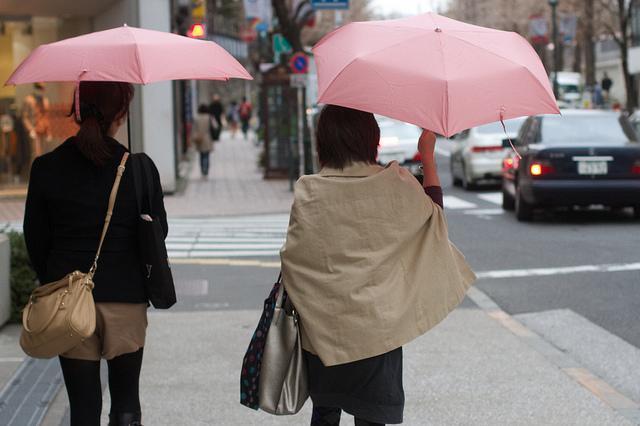How many handbags are there?
Give a very brief answer. 2. How many cars can be seen?
Give a very brief answer. 3. How many people are in the picture?
Give a very brief answer. 2. How many umbrellas are there?
Give a very brief answer. 2. How many signs have bus icon on a pole?
Give a very brief answer. 0. 